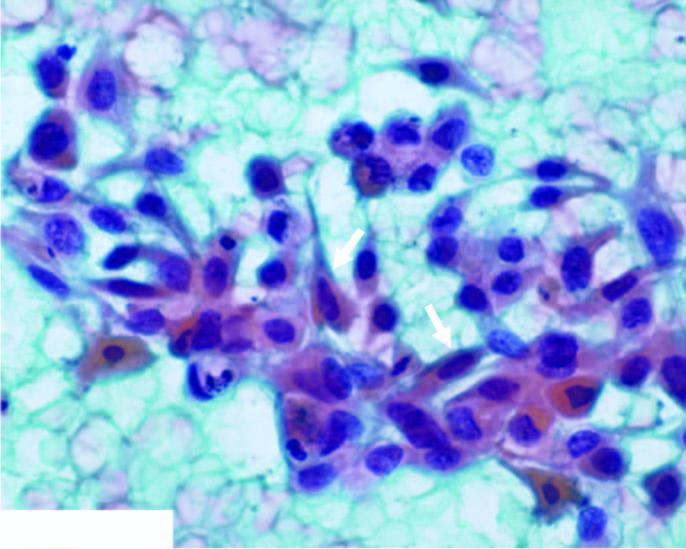what do the malignant epithelial cells have?
Answer the question using a single word or phrase. Anisonucleosis with irregular nuclear chromatin with prominent nucleoli 